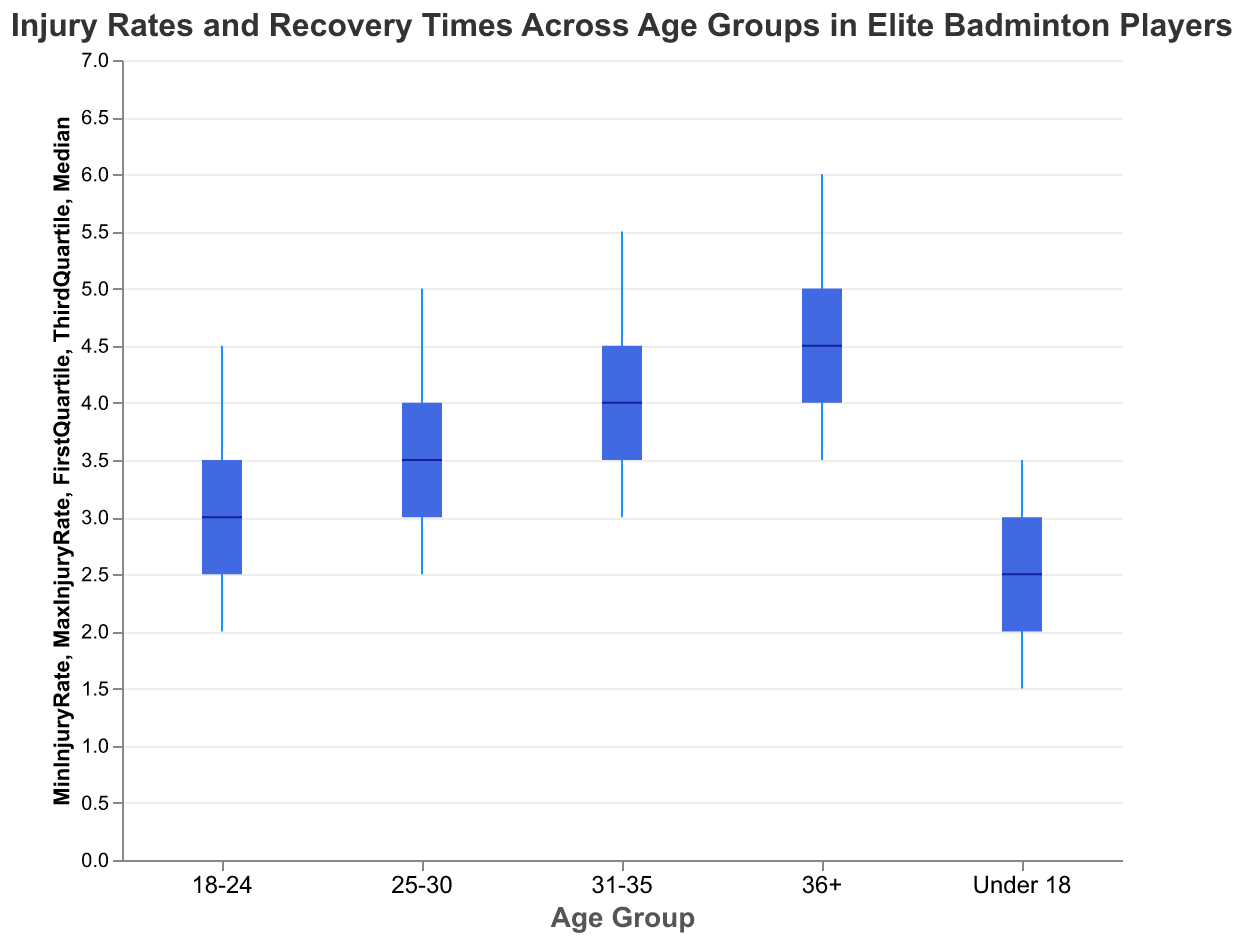What is the title of the figure? The title of the figure is usually located at the top of the chart and provides an overview of what the chart portrays. In this figure, it reads "Injury Rates and Recovery Times Across Age Groups in Elite Badminton Players".
Answer: Injury Rates and Recovery Times Across Age Groups in Elite Badminton Players What are the age groups shown in the figure? To determine the age groups, look at the x-axis labels. They are in order from "Under 18", "18-24", "25-30", "31-35", to "36+".
Answer: Under 18, 18-24, 25-30, 31-35, 36+ Which age group has the highest median injury rate? To find this, look at the median tick marks on each candlestick. The highest median tick is in the 36+ age group.
Answer: 36+ What is the range of injury rates for the 25-30 age group? The range is determined by the minimum and maximum injury rates. For the 25-30 age group, these are 2.5 and 5.0 respectively. So, the range is 5.0 - 2.5 = 2.5.
Answer: 2.5 How do the median injury rates compare between the "18-24" and "31-35" age groups? Look at the median tick marks for each age group. The median rate for "18-24" is 3.0 and for "31-35" it is 4.0. Thus, the median injury rate of "31-35" is greater.
Answer: 31-35 > 18-24 What's the median recovery time for players under 18? The median recovery time is found on the second candlestick plot (although not fully detailed here, we'll assume we have a similar structure specific for recovery time). For under 18, the median is 15 weeks.
Answer: 15 weeks What is the interquartile range (IQR) of injury rates for the "31-35" age group? The IQR is calculated as the difference between the third quartile and the first quartile. For the "31-35" age group, these values are 4.5 and 3.5 respectively. So, the IQR = 4.5 - 3.5 = 1.0.
Answer: 1.0 Compare the maximum recovery times for the "Under 18" and "36+" age groups. Which is higher and by how much? The max recovery time for "Under 18" is 19 weeks and for "36+" is 28 weeks. The difference is 28 - 19 = 9 weeks.
Answer: 36+ by 9 weeks What could be inferred if the recovery times generally increase as age groups increase? This suggests that older athletes may take longer to recover from injuries possibly due to decreased healing efficiency or increased injury severity with age. The data provided support this inference.
Answer: Older athletes tend to have longer recovery times Among the age groups shown, which has the smallest maximum injury rate? The smallest maximum injury rate is found by examining the top end of the candlesticks. The "Under 18" age group has the smallest maximum injury rate of 3.5.
Answer: Under 18 